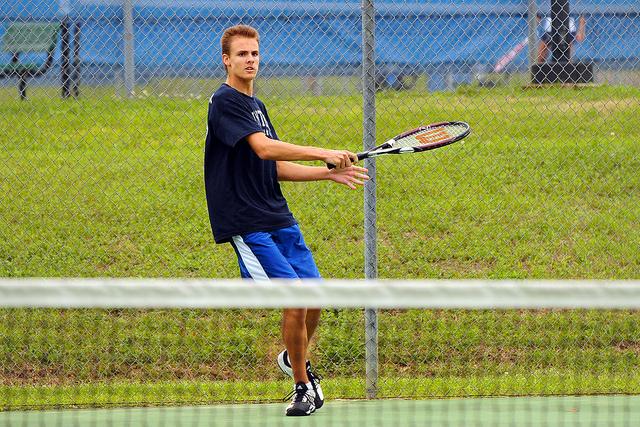What is the boy looking at?
Write a very short answer. Tennis ball. What letter is on the tennis racket?
Give a very brief answer. W. Is there a place to sit near the court?
Give a very brief answer. Yes. 